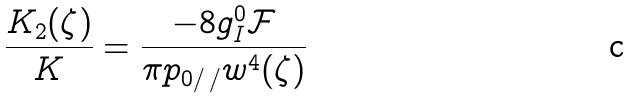<formula> <loc_0><loc_0><loc_500><loc_500>\frac { K _ { 2 } ( \zeta ) } { K } = \frac { - 8 g _ { I } ^ { 0 } \mathcal { F } } { \pi p _ { 0 / \, / } w ^ { 4 } ( \zeta ) }</formula> 